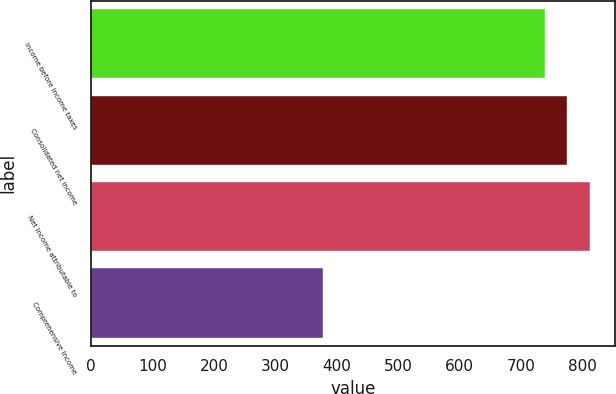<chart> <loc_0><loc_0><loc_500><loc_500><bar_chart><fcel>Income before income taxes<fcel>Consolidated net income<fcel>Net income attributable to<fcel>Comprehensive income<nl><fcel>738.8<fcel>775.67<fcel>812.54<fcel>377.3<nl></chart> 